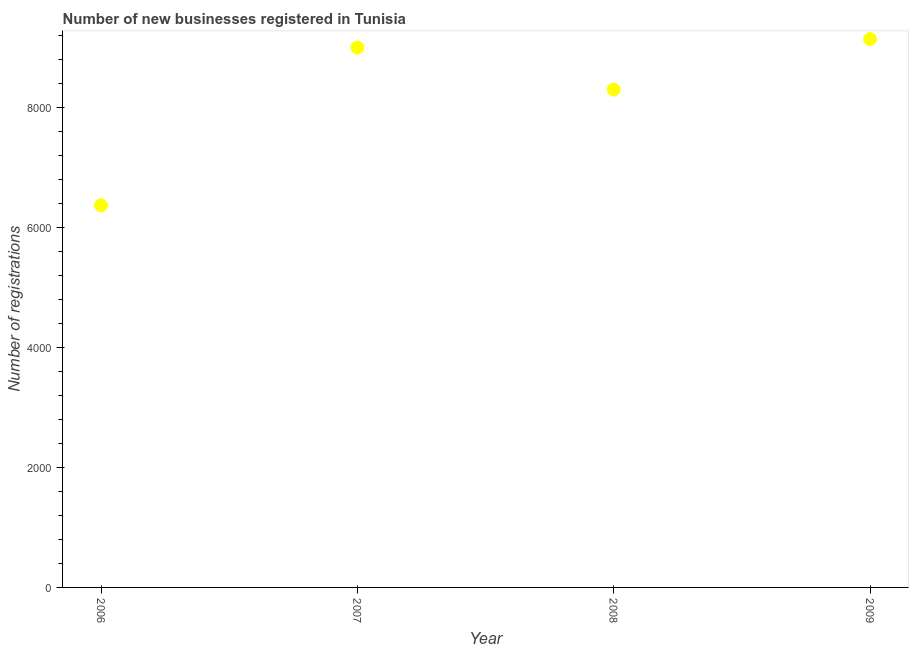What is the number of new business registrations in 2007?
Your answer should be very brief. 8997. Across all years, what is the maximum number of new business registrations?
Offer a very short reply. 9138. Across all years, what is the minimum number of new business registrations?
Your answer should be compact. 6368. In which year was the number of new business registrations maximum?
Give a very brief answer. 2009. What is the sum of the number of new business registrations?
Offer a very short reply. 3.28e+04. What is the difference between the number of new business registrations in 2007 and 2009?
Offer a very short reply. -141. What is the average number of new business registrations per year?
Keep it short and to the point. 8200. What is the median number of new business registrations?
Offer a terse response. 8647. In how many years, is the number of new business registrations greater than 800 ?
Give a very brief answer. 4. Do a majority of the years between 2009 and 2008 (inclusive) have number of new business registrations greater than 800 ?
Your answer should be very brief. No. What is the ratio of the number of new business registrations in 2007 to that in 2008?
Provide a succinct answer. 1.08. What is the difference between the highest and the second highest number of new business registrations?
Provide a succinct answer. 141. Is the sum of the number of new business registrations in 2006 and 2009 greater than the maximum number of new business registrations across all years?
Make the answer very short. Yes. What is the difference between the highest and the lowest number of new business registrations?
Provide a short and direct response. 2770. In how many years, is the number of new business registrations greater than the average number of new business registrations taken over all years?
Make the answer very short. 3. How many years are there in the graph?
Your answer should be compact. 4. What is the difference between two consecutive major ticks on the Y-axis?
Your answer should be compact. 2000. What is the title of the graph?
Provide a succinct answer. Number of new businesses registered in Tunisia. What is the label or title of the X-axis?
Make the answer very short. Year. What is the label or title of the Y-axis?
Keep it short and to the point. Number of registrations. What is the Number of registrations in 2006?
Provide a short and direct response. 6368. What is the Number of registrations in 2007?
Keep it short and to the point. 8997. What is the Number of registrations in 2008?
Provide a short and direct response. 8297. What is the Number of registrations in 2009?
Your answer should be compact. 9138. What is the difference between the Number of registrations in 2006 and 2007?
Keep it short and to the point. -2629. What is the difference between the Number of registrations in 2006 and 2008?
Provide a succinct answer. -1929. What is the difference between the Number of registrations in 2006 and 2009?
Provide a succinct answer. -2770. What is the difference between the Number of registrations in 2007 and 2008?
Provide a succinct answer. 700. What is the difference between the Number of registrations in 2007 and 2009?
Your response must be concise. -141. What is the difference between the Number of registrations in 2008 and 2009?
Offer a terse response. -841. What is the ratio of the Number of registrations in 2006 to that in 2007?
Give a very brief answer. 0.71. What is the ratio of the Number of registrations in 2006 to that in 2008?
Provide a succinct answer. 0.77. What is the ratio of the Number of registrations in 2006 to that in 2009?
Keep it short and to the point. 0.7. What is the ratio of the Number of registrations in 2007 to that in 2008?
Your response must be concise. 1.08. What is the ratio of the Number of registrations in 2008 to that in 2009?
Provide a short and direct response. 0.91. 